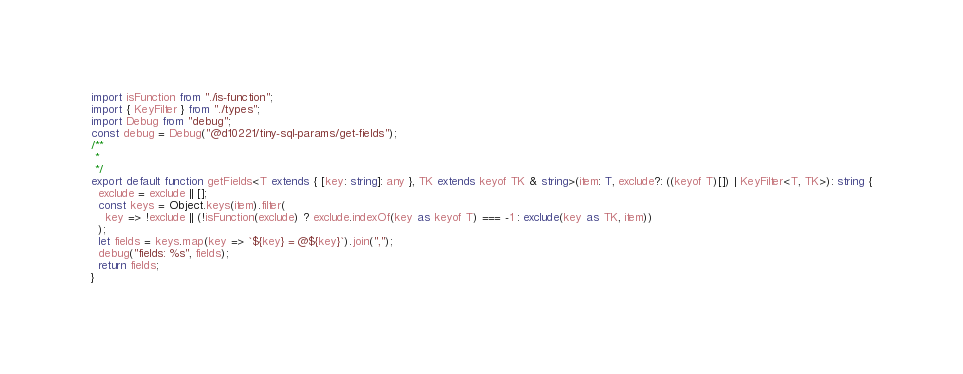Convert code to text. <code><loc_0><loc_0><loc_500><loc_500><_TypeScript_>import isFunction from "./is-function";
import { KeyFilter } from "./types";
import Debug from "debug";
const debug = Debug("@d10221/tiny-sql-params/get-fields");
/**
 * 
 */
export default function getFields<T extends { [key: string]: any }, TK extends keyof TK & string>(item: T, exclude?: ((keyof T)[]) | KeyFilter<T, TK>): string {
  exclude = exclude || [];
  const keys = Object.keys(item).filter(
    key => !exclude || (!isFunction(exclude) ? exclude.indexOf(key as keyof T) === -1 : exclude(key as TK, item))
  );
  let fields = keys.map(key => `${key} = @${key}`).join(",");
  debug("fields: %s", fields);
  return fields;
}
</code> 